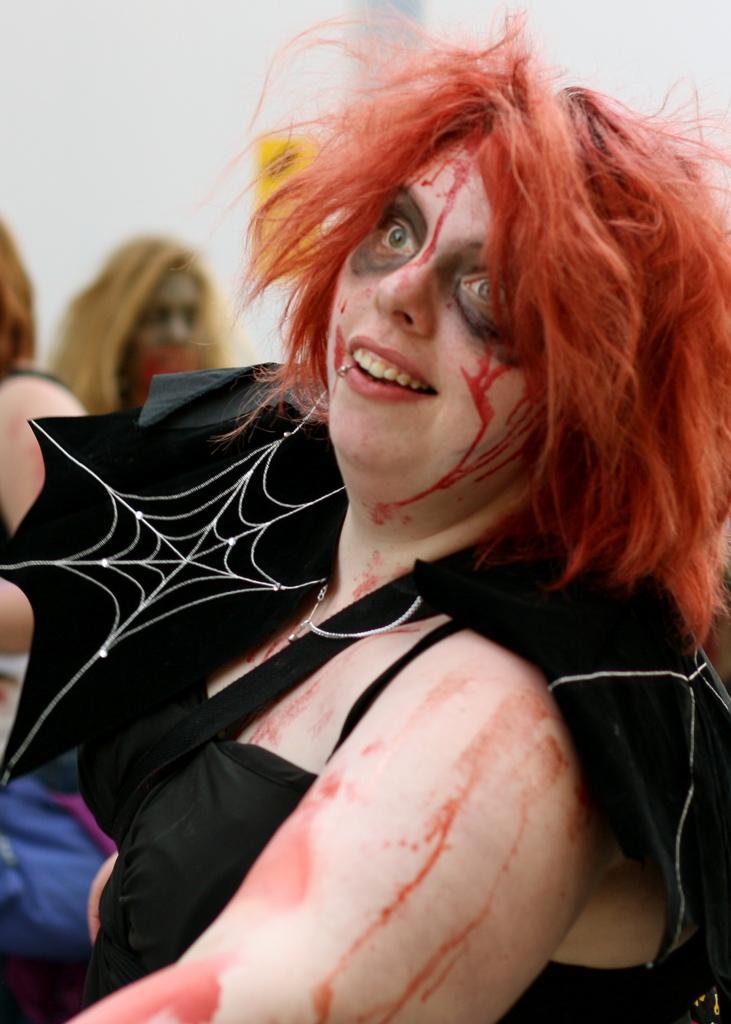Could you give a brief overview of what you see in this image? In this image I can see a person wearing black color dress, background I can see few other persons sitting and the wall is in white color. 